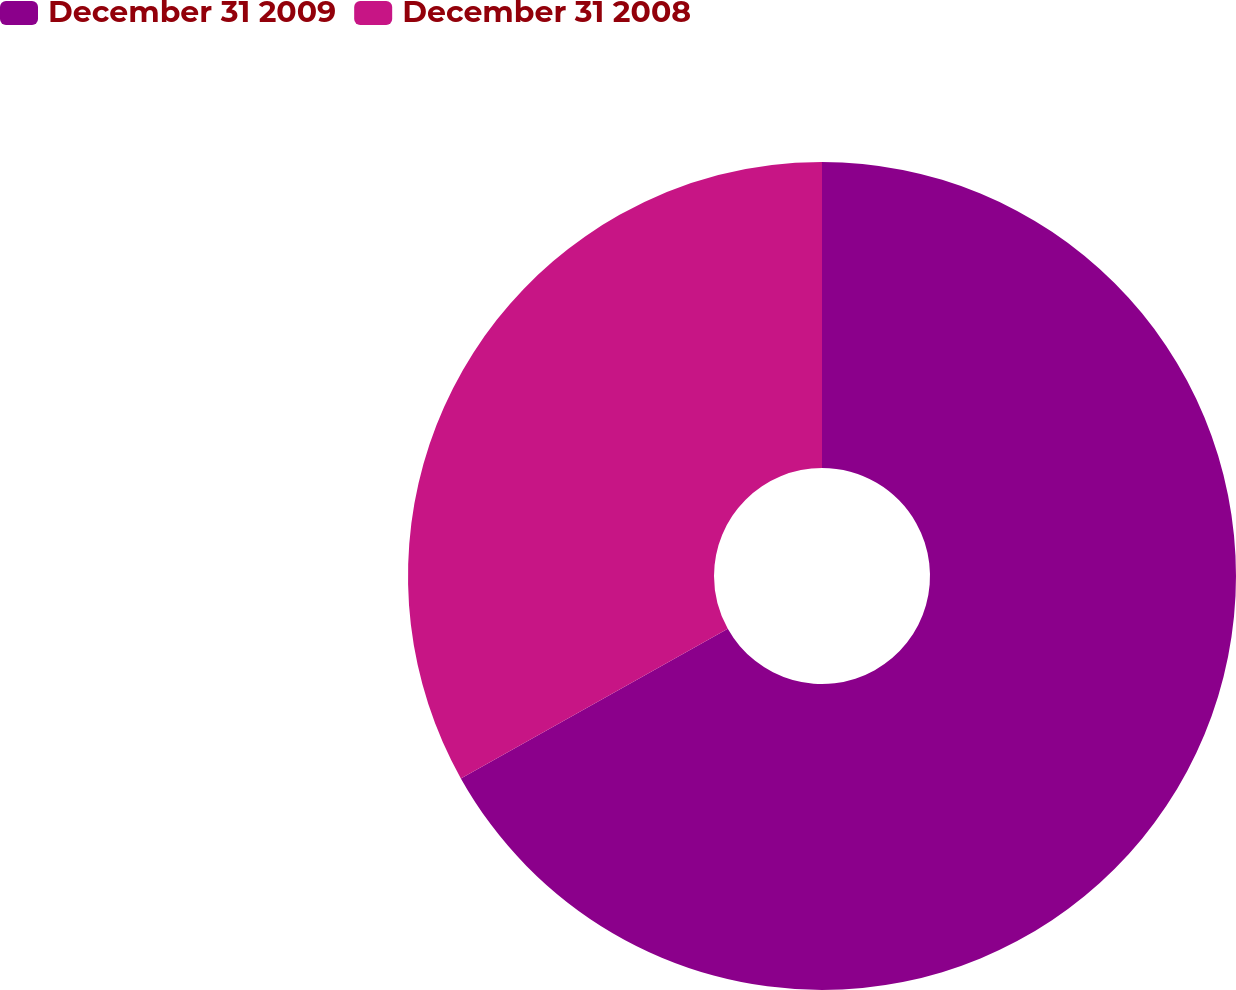<chart> <loc_0><loc_0><loc_500><loc_500><pie_chart><fcel>December 31 2009<fcel>December 31 2008<nl><fcel>66.87%<fcel>33.13%<nl></chart> 